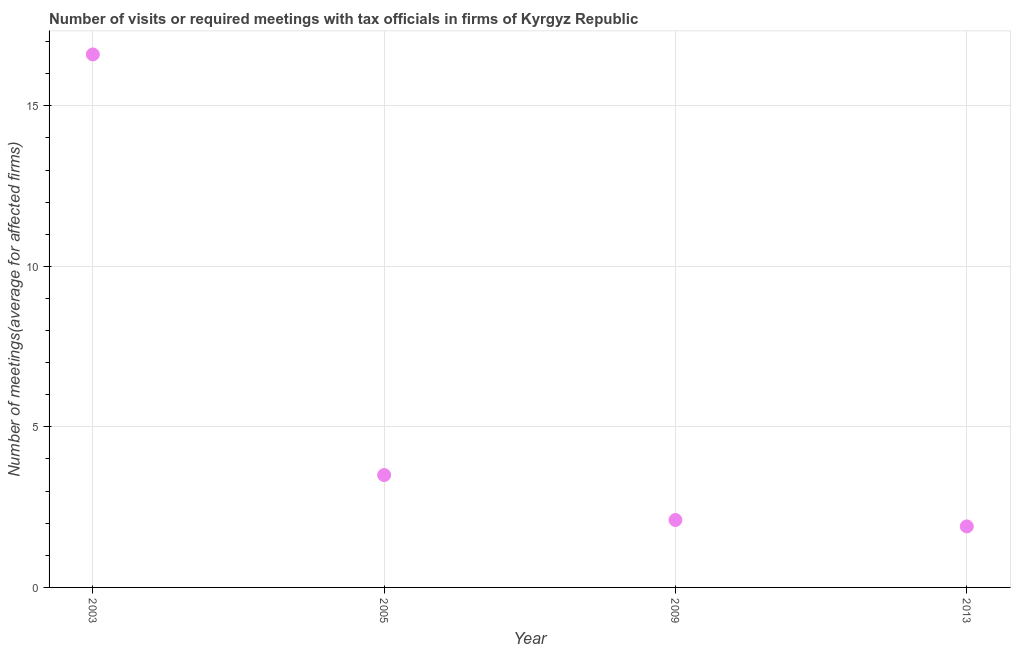Across all years, what is the maximum number of required meetings with tax officials?
Your response must be concise. 16.6. Across all years, what is the minimum number of required meetings with tax officials?
Your response must be concise. 1.9. What is the sum of the number of required meetings with tax officials?
Provide a succinct answer. 24.1. What is the difference between the number of required meetings with tax officials in 2003 and 2009?
Offer a terse response. 14.5. What is the average number of required meetings with tax officials per year?
Offer a very short reply. 6.03. In how many years, is the number of required meetings with tax officials greater than 16 ?
Ensure brevity in your answer.  1. Do a majority of the years between 2003 and 2009 (inclusive) have number of required meetings with tax officials greater than 13 ?
Provide a short and direct response. No. What is the ratio of the number of required meetings with tax officials in 2005 to that in 2013?
Your answer should be compact. 1.84. What is the difference between the highest and the second highest number of required meetings with tax officials?
Give a very brief answer. 13.1. Is the sum of the number of required meetings with tax officials in 2009 and 2013 greater than the maximum number of required meetings with tax officials across all years?
Your answer should be very brief. No. What is the difference between the highest and the lowest number of required meetings with tax officials?
Your answer should be very brief. 14.7. Does the graph contain any zero values?
Your answer should be compact. No. What is the title of the graph?
Ensure brevity in your answer.  Number of visits or required meetings with tax officials in firms of Kyrgyz Republic. What is the label or title of the Y-axis?
Offer a very short reply. Number of meetings(average for affected firms). What is the Number of meetings(average for affected firms) in 2005?
Offer a terse response. 3.5. What is the Number of meetings(average for affected firms) in 2013?
Make the answer very short. 1.9. What is the difference between the Number of meetings(average for affected firms) in 2005 and 2013?
Offer a terse response. 1.6. What is the difference between the Number of meetings(average for affected firms) in 2009 and 2013?
Offer a terse response. 0.2. What is the ratio of the Number of meetings(average for affected firms) in 2003 to that in 2005?
Give a very brief answer. 4.74. What is the ratio of the Number of meetings(average for affected firms) in 2003 to that in 2009?
Ensure brevity in your answer.  7.91. What is the ratio of the Number of meetings(average for affected firms) in 2003 to that in 2013?
Offer a terse response. 8.74. What is the ratio of the Number of meetings(average for affected firms) in 2005 to that in 2009?
Keep it short and to the point. 1.67. What is the ratio of the Number of meetings(average for affected firms) in 2005 to that in 2013?
Your response must be concise. 1.84. What is the ratio of the Number of meetings(average for affected firms) in 2009 to that in 2013?
Your answer should be compact. 1.1. 